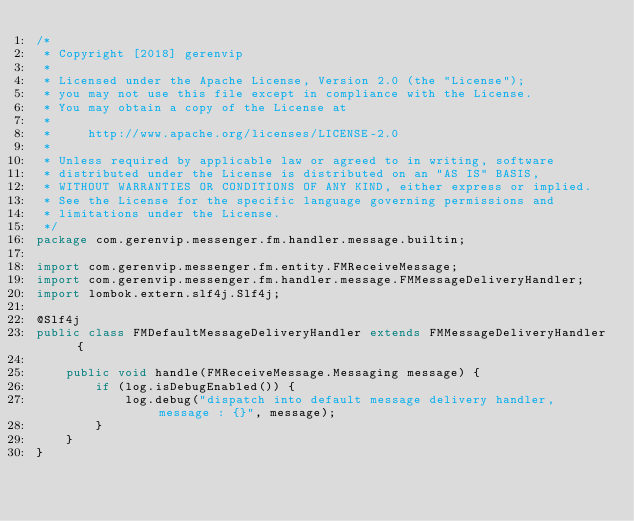<code> <loc_0><loc_0><loc_500><loc_500><_Java_>/*
 * Copyright [2018] gerenvip
 *
 * Licensed under the Apache License, Version 2.0 (the "License");
 * you may not use this file except in compliance with the License.
 * You may obtain a copy of the License at
 *
 *     http://www.apache.org/licenses/LICENSE-2.0
 *
 * Unless required by applicable law or agreed to in writing, software
 * distributed under the License is distributed on an "AS IS" BASIS,
 * WITHOUT WARRANTIES OR CONDITIONS OF ANY KIND, either express or implied.
 * See the License for the specific language governing permissions and
 * limitations under the License.
 */
package com.gerenvip.messenger.fm.handler.message.builtin;

import com.gerenvip.messenger.fm.entity.FMReceiveMessage;
import com.gerenvip.messenger.fm.handler.message.FMMessageDeliveryHandler;
import lombok.extern.slf4j.Slf4j;

@Slf4j
public class FMDefaultMessageDeliveryHandler extends FMMessageDeliveryHandler {

    public void handle(FMReceiveMessage.Messaging message) {
        if (log.isDebugEnabled()) {
            log.debug("dispatch into default message delivery handler, message : {}", message);
        }
    }
}
</code> 